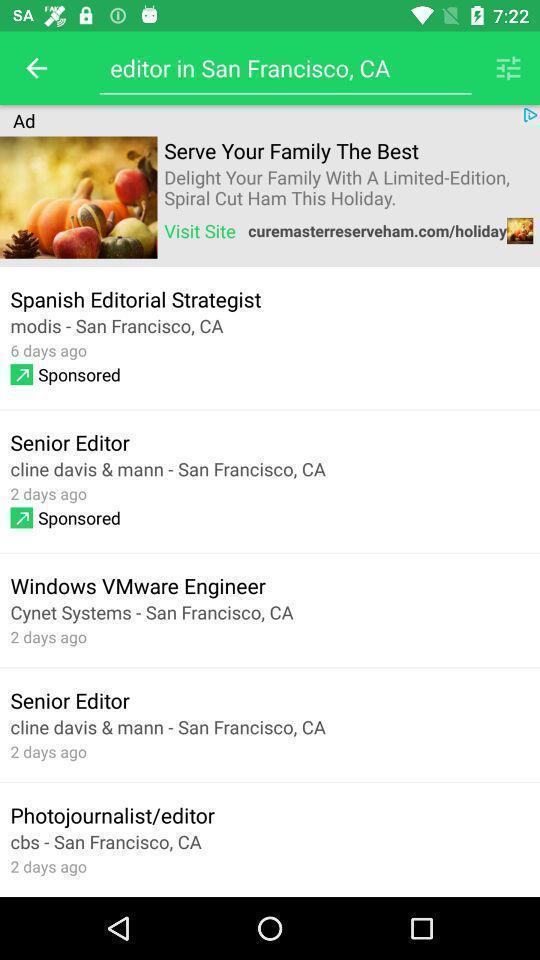Please provide a description for this image. Search page showing information about a person. 